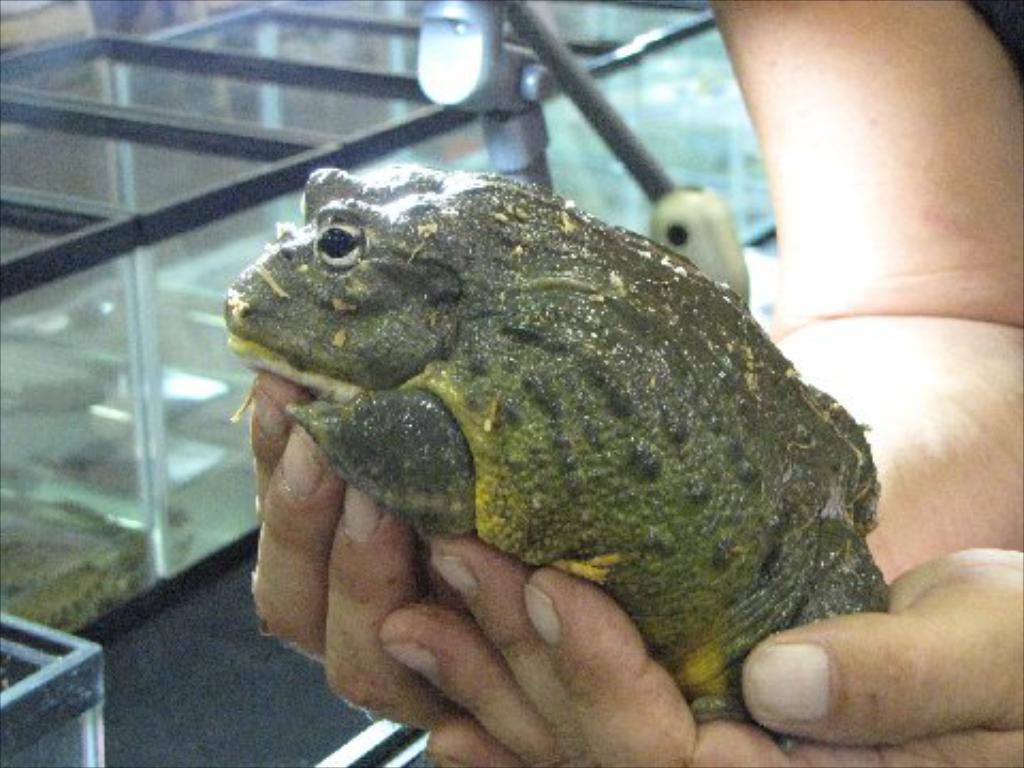Can you describe this image briefly? As we can see in the image there is a human hand holding a frog and there are boxes. 